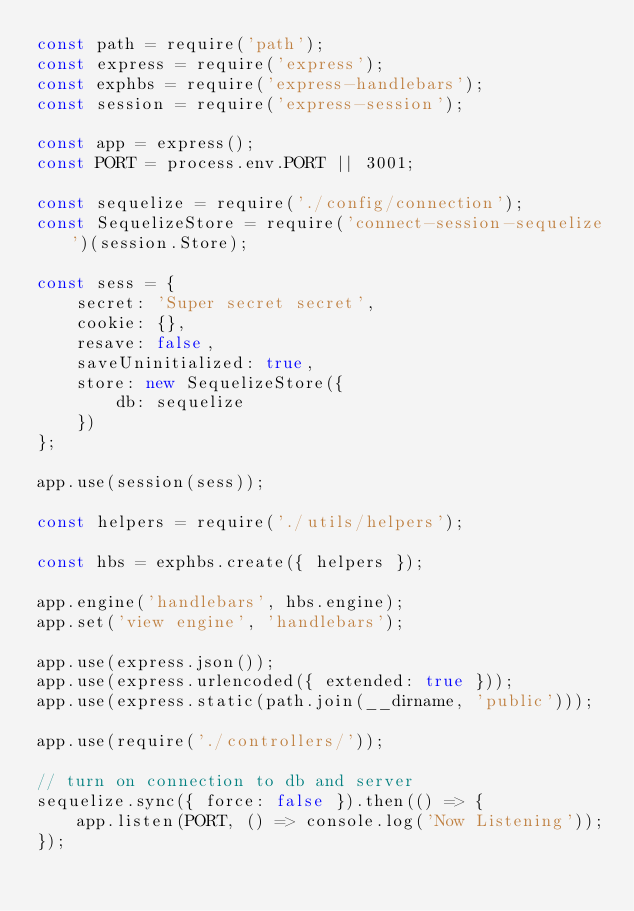<code> <loc_0><loc_0><loc_500><loc_500><_JavaScript_>const path = require('path');
const express = require('express');
const exphbs = require('express-handlebars');
const session = require('express-session');

const app = express();
const PORT = process.env.PORT || 3001;

const sequelize = require('./config/connection');
const SequelizeStore = require('connect-session-sequelize')(session.Store);

const sess = {
    secret: 'Super secret secret',
    cookie: {},
    resave: false,
    saveUninitialized: true,
    store: new SequelizeStore({
        db: sequelize
    })
};

app.use(session(sess));

const helpers = require('./utils/helpers');

const hbs = exphbs.create({ helpers });

app.engine('handlebars', hbs.engine);
app.set('view engine', 'handlebars');

app.use(express.json());
app.use(express.urlencoded({ extended: true }));
app.use(express.static(path.join(__dirname, 'public')));

app.use(require('./controllers/'));

// turn on connection to db and server
sequelize.sync({ force: false }).then(() => {
    app.listen(PORT, () => console.log('Now Listening'));
});</code> 